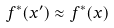<formula> <loc_0><loc_0><loc_500><loc_500>f ^ { * } ( x ^ { \prime } ) \approx f ^ { * } ( x )</formula> 